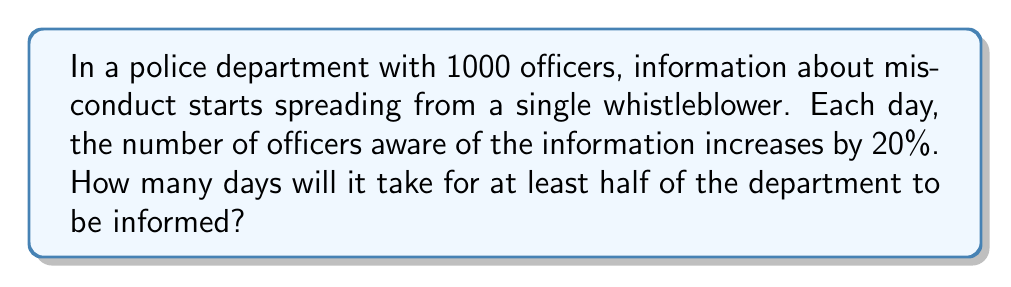Could you help me with this problem? Let's approach this step-by-step:

1) We can model this scenario with an exponential function:
   $N(t) = 1 \cdot (1.20)^t$
   Where $N(t)$ is the number of informed officers after $t$ days.

2) We need to find $t$ when $N(t) \geq 500$ (half of 1000 officers):
   $1 \cdot (1.20)^t \geq 500$

3) Taking logarithms of both sides:
   $\log(1.20)^t \geq \log(500)$

4) Using the logarithm property $\log(a^b) = b\log(a)$:
   $t \cdot \log(1.20) \geq \log(500)$

5) Solving for $t$:
   $t \geq \frac{\log(500)}{\log(1.20)}$

6) Using a calculator:
   $t \geq \frac{2.69897}{0.07918} \approx 34.0874$

7) Since $t$ must be a whole number of days, we round up to the next integer.
Answer: 35 days 